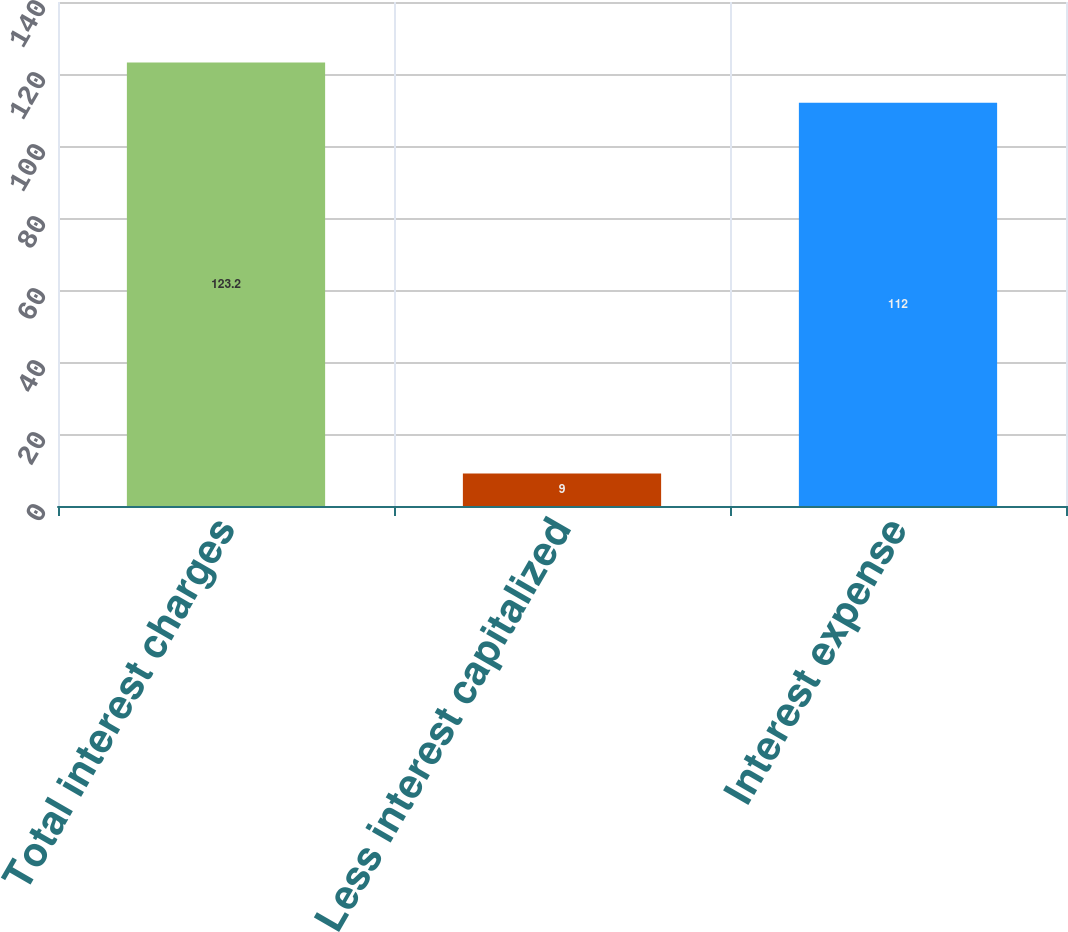Convert chart. <chart><loc_0><loc_0><loc_500><loc_500><bar_chart><fcel>Total interest charges<fcel>Less interest capitalized<fcel>Interest expense<nl><fcel>123.2<fcel>9<fcel>112<nl></chart> 